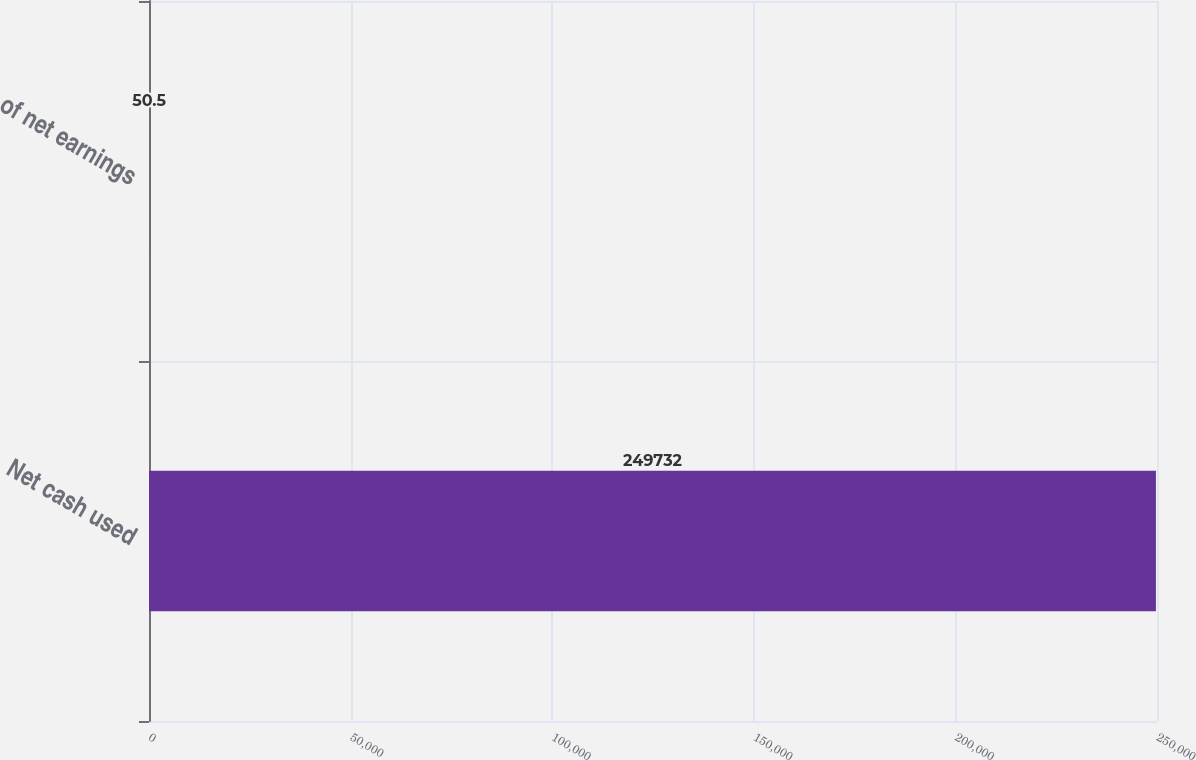Convert chart. <chart><loc_0><loc_0><loc_500><loc_500><bar_chart><fcel>Net cash used<fcel>of net earnings<nl><fcel>249732<fcel>50.5<nl></chart> 